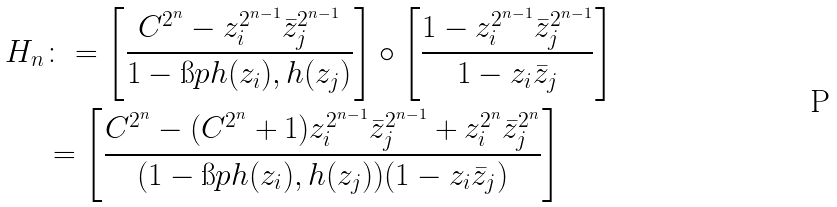<formula> <loc_0><loc_0><loc_500><loc_500>H _ { n } & \colon = \left [ \frac { C ^ { 2 ^ { n } } - z _ { i } ^ { 2 ^ { n - 1 } } \bar { z } _ { j } ^ { 2 ^ { n - 1 } } } { 1 - \i p { h ( z _ { i } ) , h ( z _ { j } ) } } \right ] \circ \left [ \frac { 1 - z _ { i } ^ { 2 ^ { n - 1 } } \bar { z } _ { j } ^ { 2 ^ { n - 1 } } } { 1 - z _ { i } \bar { z } _ { j } } \right ] \\ & = \left [ \frac { C ^ { 2 ^ { n } } - ( C ^ { 2 ^ { n } } + 1 ) z _ { i } ^ { 2 ^ { n - 1 } } \bar { z } _ { j } ^ { 2 ^ { n - 1 } } + z _ { i } ^ { 2 ^ { n } } \bar { z } _ { j } ^ { 2 ^ { n } } } { ( 1 - \i p { h ( z _ { i } ) , h ( z _ { j } ) } ) ( 1 - z _ { i } \bar { z } _ { j } ) } \right ]</formula> 